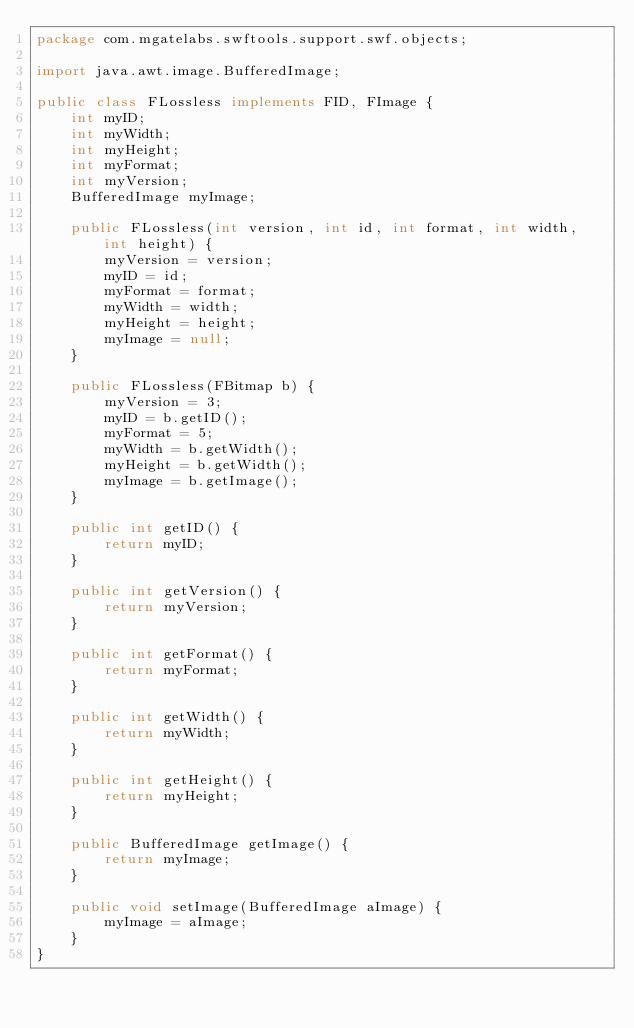<code> <loc_0><loc_0><loc_500><loc_500><_Java_>package com.mgatelabs.swftools.support.swf.objects;

import java.awt.image.BufferedImage;

public class FLossless implements FID, FImage {
    int myID;
    int myWidth;
    int myHeight;
    int myFormat;
    int myVersion;
    BufferedImage myImage;

    public FLossless(int version, int id, int format, int width, int height) {
        myVersion = version;
        myID = id;
        myFormat = format;
        myWidth = width;
        myHeight = height;
        myImage = null;
    }

    public FLossless(FBitmap b) {
        myVersion = 3;
        myID = b.getID();
        myFormat = 5;
        myWidth = b.getWidth();
        myHeight = b.getWidth();
        myImage = b.getImage();
    }

    public int getID() {
        return myID;
    }

    public int getVersion() {
        return myVersion;
    }

    public int getFormat() {
        return myFormat;
    }

    public int getWidth() {
        return myWidth;
    }

    public int getHeight() {
        return myHeight;
    }

    public BufferedImage getImage() {
        return myImage;
    }

    public void setImage(BufferedImage aImage) {
        myImage = aImage;
    }
}</code> 